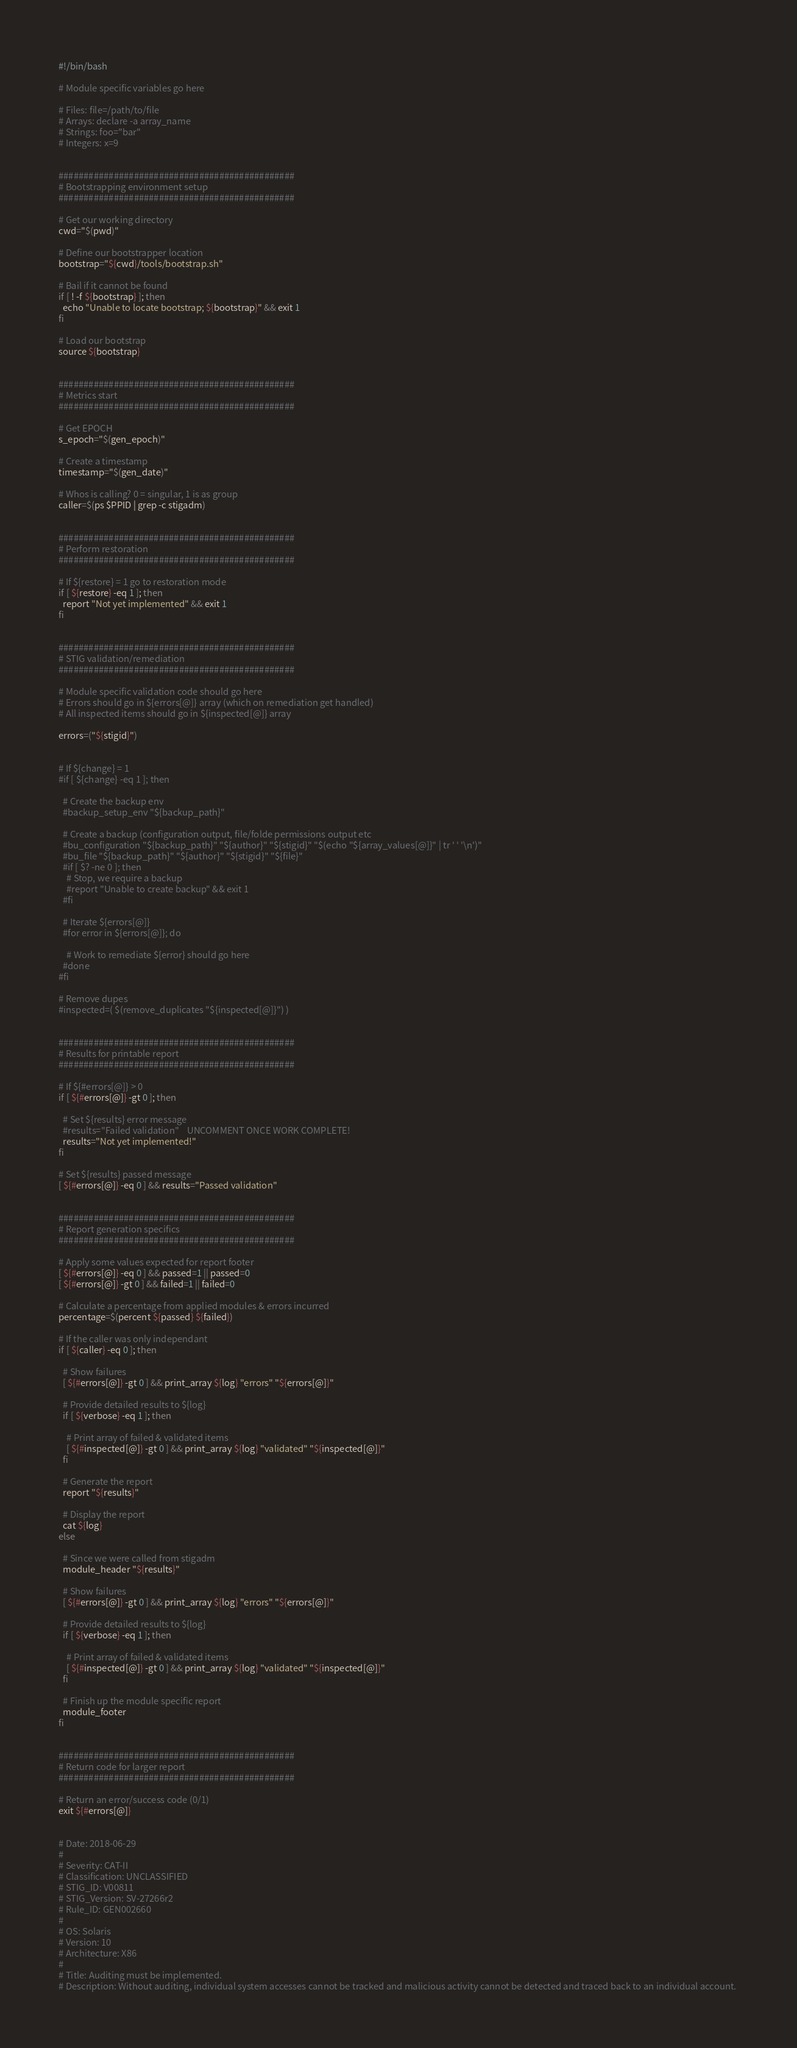Convert code to text. <code><loc_0><loc_0><loc_500><loc_500><_Bash_>#!/bin/bash

# Module specific variables go here

# Files: file=/path/to/file
# Arrays: declare -a array_name
# Strings: foo="bar"
# Integers: x=9


###############################################
# Bootstrapping environment setup
###############################################

# Get our working directory
cwd="$(pwd)"

# Define our bootstrapper location
bootstrap="${cwd}/tools/bootstrap.sh"

# Bail if it cannot be found
if [ ! -f ${bootstrap} ]; then
  echo "Unable to locate bootstrap; ${bootstrap}" && exit 1
fi

# Load our bootstrap
source ${bootstrap}


###############################################
# Metrics start
###############################################

# Get EPOCH
s_epoch="$(gen_epoch)"

# Create a timestamp
timestamp="$(gen_date)"

# Whos is calling? 0 = singular, 1 is as group
caller=$(ps $PPID | grep -c stigadm)


###############################################
# Perform restoration
###############################################

# If ${restore} = 1 go to restoration mode
if [ ${restore} -eq 1 ]; then
  report "Not yet implemented" && exit 1
fi


###############################################
# STIG validation/remediation
###############################################

# Module specific validation code should go here
# Errors should go in ${errors[@]} array (which on remediation get handled)
# All inspected items should go in ${inspected[@]} array

errors=("${stigid}")


# If ${change} = 1
#if [ ${change} -eq 1 ]; then

  # Create the backup env
  #backup_setup_env "${backup_path}"

  # Create a backup (configuration output, file/folde permissions output etc
  #bu_configuration "${backup_path}" "${author}" "${stigid}" "$(echo "${array_values[@]}" | tr ' ' '\n')"
  #bu_file "${backup_path}" "${author}" "${stigid}" "${file}"
  #if [ $? -ne 0 ]; then
    # Stop, we require a backup
    #report "Unable to create backup" && exit 1
  #fi

  # Iterate ${errors[@]}
  #for error in ${errors[@]}; do

    # Work to remediate ${error} should go here
  #done
#fi

# Remove dupes
#inspected=( $(remove_duplicates "${inspected[@]}") )


###############################################
# Results for printable report
###############################################

# If ${#errors[@]} > 0
if [ ${#errors[@]} -gt 0 ]; then

  # Set ${results} error message
  #results="Failed validation"    UNCOMMENT ONCE WORK COMPLETE!
  results="Not yet implemented!"
fi

# Set ${results} passed message
[ ${#errors[@]} -eq 0 ] && results="Passed validation"


###############################################
# Report generation specifics
###############################################

# Apply some values expected for report footer
[ ${#errors[@]} -eq 0 ] && passed=1 || passed=0
[ ${#errors[@]} -gt 0 ] && failed=1 || failed=0

# Calculate a percentage from applied modules & errors incurred
percentage=$(percent ${passed} ${failed})

# If the caller was only independant
if [ ${caller} -eq 0 ]; then

  # Show failures
  [ ${#errors[@]} -gt 0 ] && print_array ${log} "errors" "${errors[@]}"

  # Provide detailed results to ${log}
  if [ ${verbose} -eq 1 ]; then

    # Print array of failed & validated items
    [ ${#inspected[@]} -gt 0 ] && print_array ${log} "validated" "${inspected[@]}"
  fi

  # Generate the report
  report "${results}"

  # Display the report
  cat ${log}
else

  # Since we were called from stigadm
  module_header "${results}"

  # Show failures
  [ ${#errors[@]} -gt 0 ] && print_array ${log} "errors" "${errors[@]}"

  # Provide detailed results to ${log}
  if [ ${verbose} -eq 1 ]; then

    # Print array of failed & validated items
    [ ${#inspected[@]} -gt 0 ] && print_array ${log} "validated" "${inspected[@]}"
  fi

  # Finish up the module specific report
  module_footer
fi


###############################################
# Return code for larger report
###############################################

# Return an error/success code (0/1)
exit ${#errors[@]}


# Date: 2018-06-29
#
# Severity: CAT-II
# Classification: UNCLASSIFIED
# STIG_ID: V00811
# STIG_Version: SV-27266r2
# Rule_ID: GEN002660
#
# OS: Solaris
# Version: 10
# Architecture: X86
#
# Title: Auditing must be implemented.
# Description: Without auditing, individual system accesses cannot be tracked and malicious activity cannot be detected and traced back to an individual account. 

</code> 